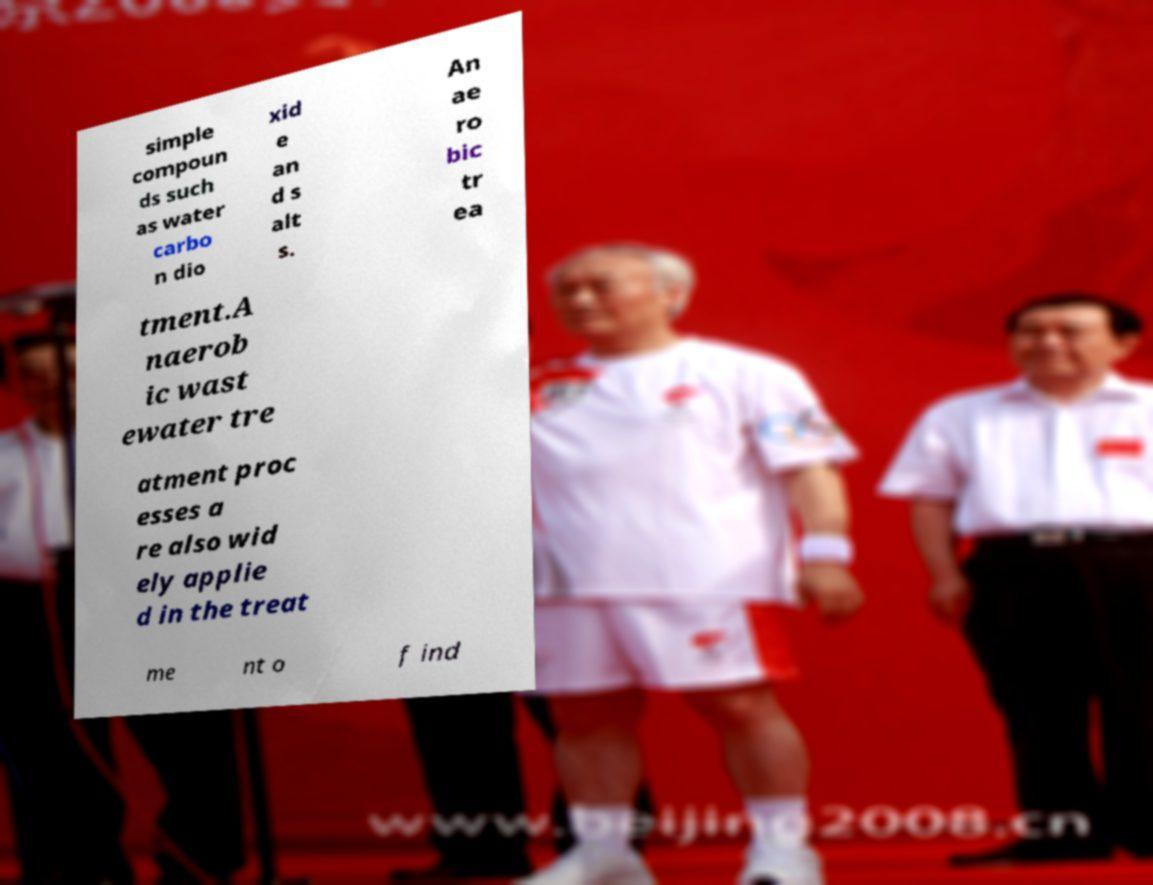I need the written content from this picture converted into text. Can you do that? simple compoun ds such as water carbo n dio xid e an d s alt s. An ae ro bic tr ea tment.A naerob ic wast ewater tre atment proc esses a re also wid ely applie d in the treat me nt o f ind 